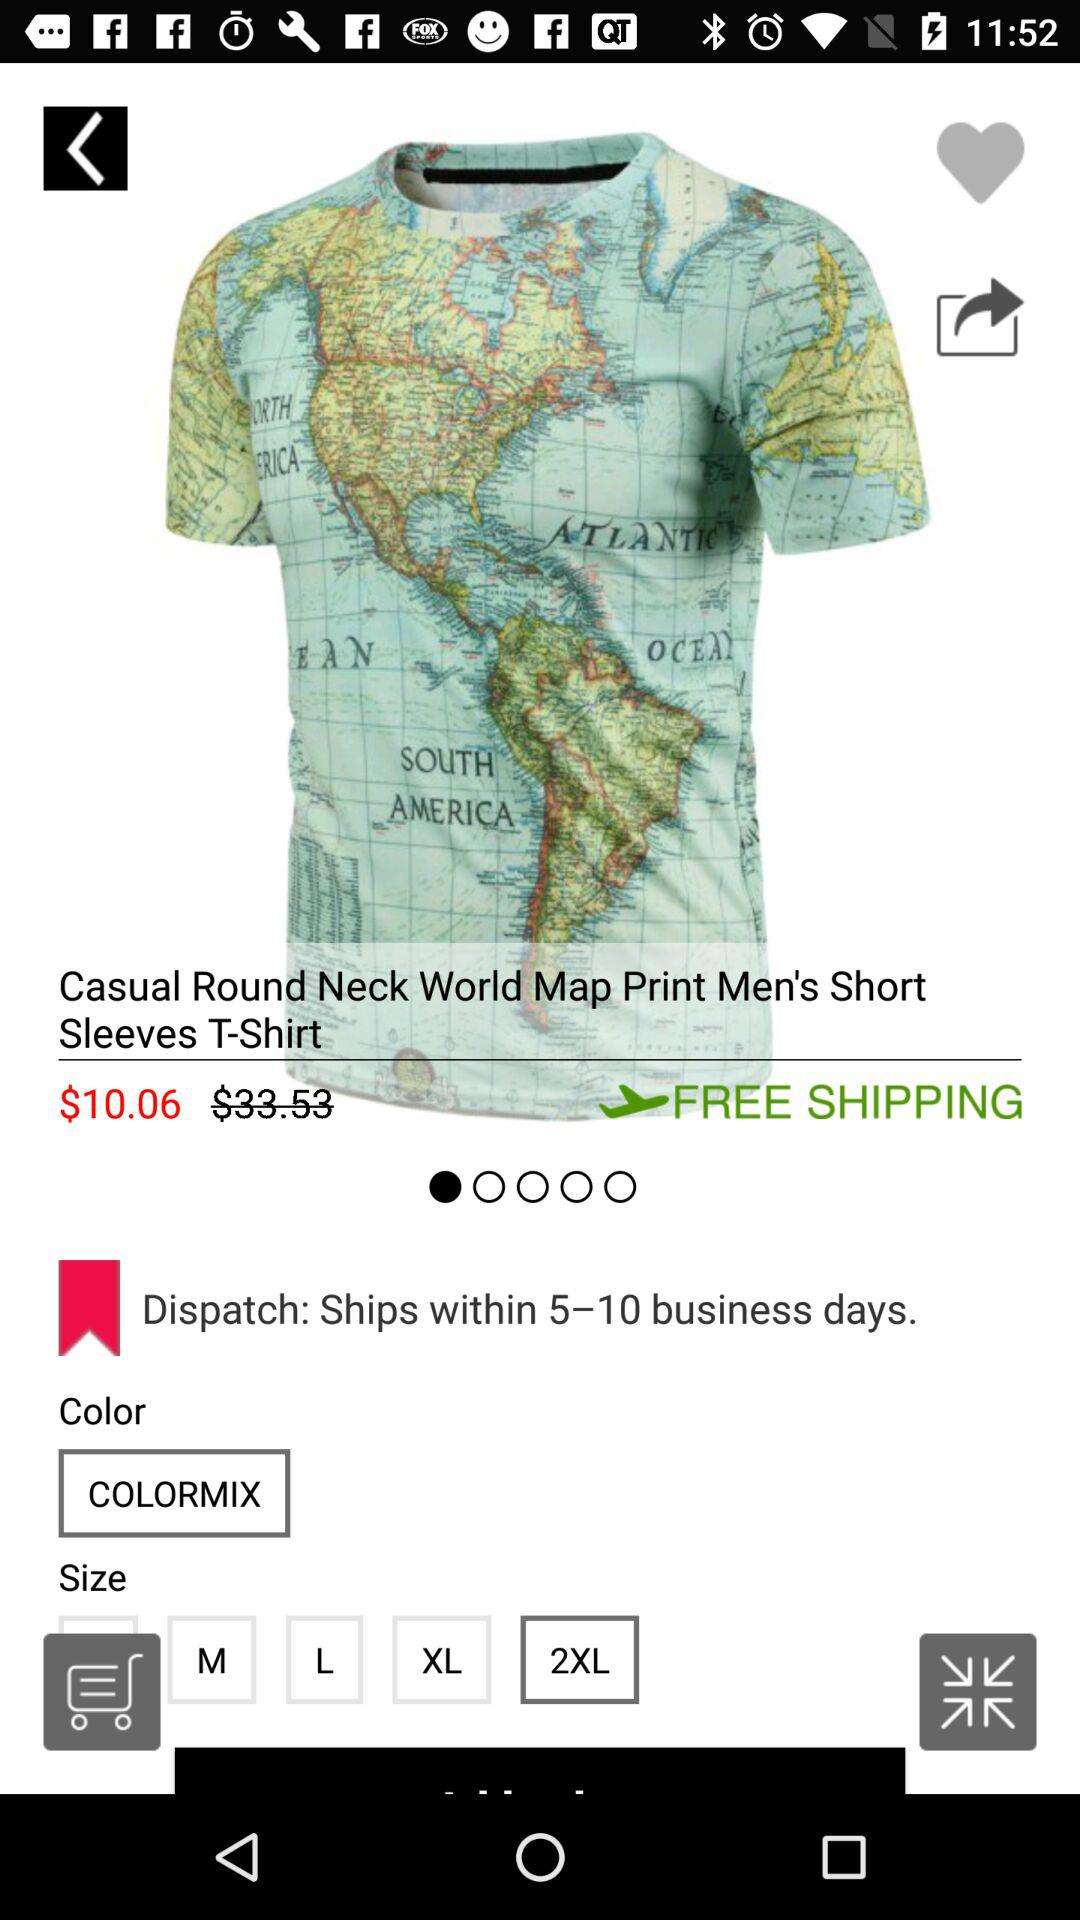Which is the selected size? The selected size is 2XL. 